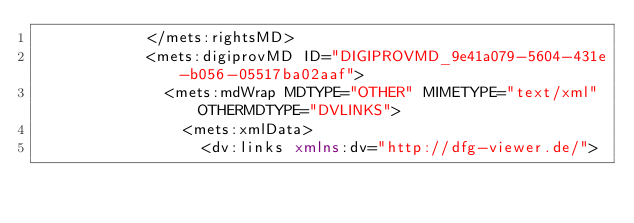<code> <loc_0><loc_0><loc_500><loc_500><_XML_>            </mets:rightsMD>
            <mets:digiprovMD ID="DIGIPROVMD_9e41a079-5604-431e-b056-05517ba02aaf">
              <mets:mdWrap MDTYPE="OTHER" MIMETYPE="text/xml" OTHERMDTYPE="DVLINKS">
                <mets:xmlData>
                  <dv:links xmlns:dv="http://dfg-viewer.de/"></code> 